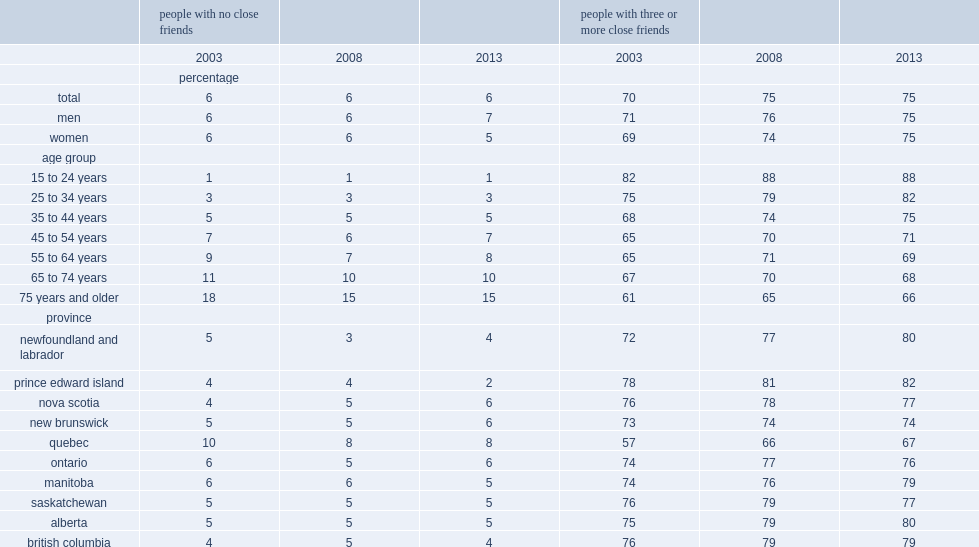What is the percentage of canadians who reported having no close friends in 2013? 6.0. What is the percentage of seniors aged 75 years and older reported having no friends in 2013? 15.0. What is the percentage of persons aged aged 35 to 44 reported having no friends in 2013? 5.0. What is the percentage of canadians aged 75 and older not living in an institution who had no close friends they could confide in or call on for help in 2013? 15.0. Which province has the lowest proportion of people who reported having no close friends in 2013? Prince edward island. Which province has the highest proportion of people who reported having no close friends in 2013? Quebec. 